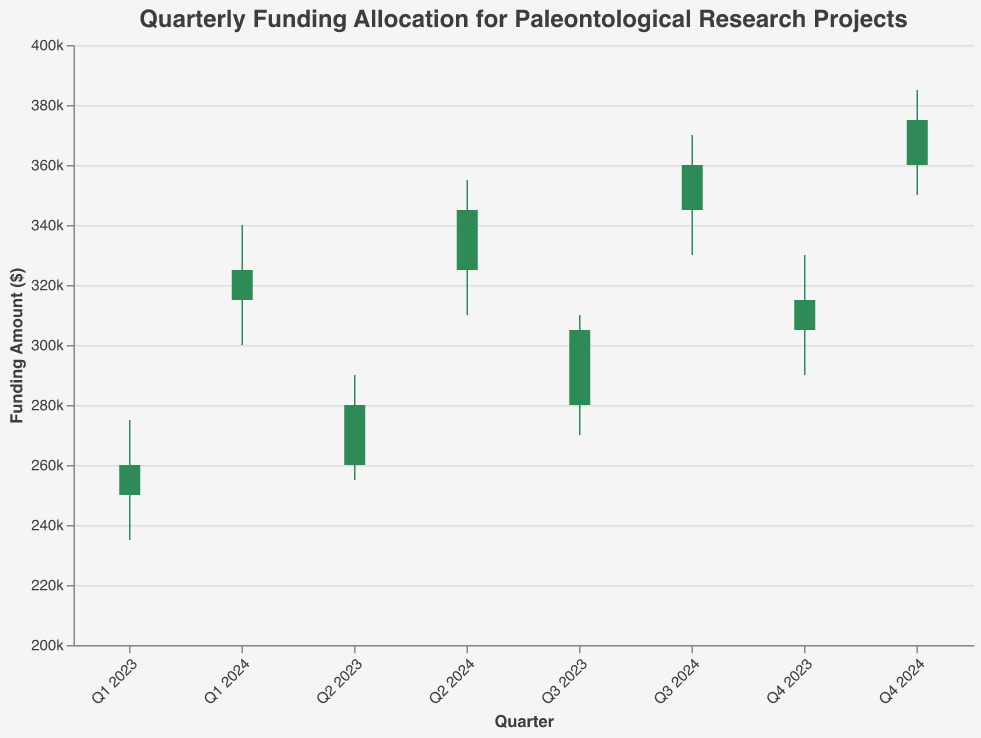What's the title of the chart? The title of the chart is displayed at the top center of the figure. It reads, "Quarterly Funding Allocation for Paleontological Research Projects."
Answer: Quarterly Funding Allocation for Paleontological Research Projects How does the funding allocation change from Q3 2023 to Q1 2024? To determine the change in funding allocation, compare the opening value of Q3 2023 with the closing value of Q1 2024. The opening value for Q3 2023 is $280,000, and the closing value for Q1 2024 is $325,000. The difference is $325,000 - $280,000.
Answer: Increase of $45,000 Which quarter had the highest funding allocation? To find the quarter with the highest funding allocation, look at the "High" values for each quarter and identify the maximum value. The highest value recorded is $385,000 in Q4 2024.
Answer: Q4 2024 During which quarter did the funding allocation decrease compared to the previous quarter? To determine when funding allocation decreased, compare the close value of each quarter with the open value of the following quarter. There is no such quarter in the given data.
Answer: None What was the lowest funding allocation recorded in Q1 2023? Find the "Low" value for Q1 2023 in the dataset. The value for Q1 2023 "Low" is $235,000.
Answer: $235,000 How many quarters exhibited an increase in funding allocation from the open to the close value? Count the number of quarters where the "Close" value is greater than the "Open" value. All quarters (Q1 2023 to Q4 2024) show an increase from the open to close value.
Answer: 8 quarters Compare the funding allocation at the end of Q2 2023 with the start of Q3 2023. Which was higher? Compare the close value of Q2 2023 ($280,000) with the open value of Q3 2023 ($280,000). Both values are identical.
Answer: Both are equal What is the difference between the highest and lowest funding allocations recorded in 2024? Identify the highest and lowest values for 2024. The highest is $385,000 (Q4), and the lowest is $300,000 (Q1). The difference is $385,000 - $300,000.
Answer: $85,000 During which quarter was the range between the high and low funding allocation the smallest? The range is given by (High - Low) for each quarter. Calculate and compare these values. The smallest range is in Q1 2023, where the range is $275,000 - $235,000 = $40,000.
Answer: Q1 2023 Which quarter had the highest closing funding allocation within 2023? Inspect the "Close" values for each quarter in 2023 and find the quarter with the highest closing value. Q4 2023 had the highest closing value of $315,000.
Answer: Q4 2023 